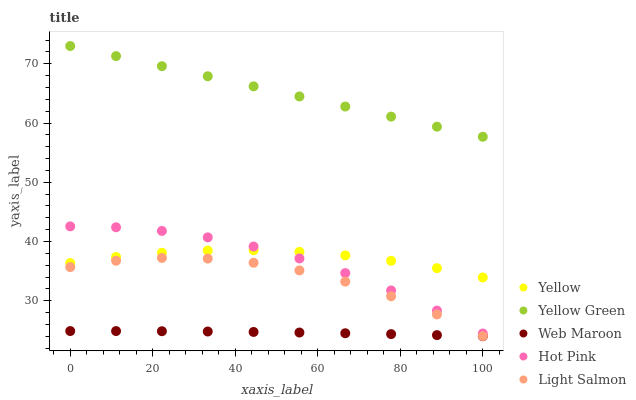Does Web Maroon have the minimum area under the curve?
Answer yes or no. Yes. Does Yellow Green have the maximum area under the curve?
Answer yes or no. Yes. Does Hot Pink have the minimum area under the curve?
Answer yes or no. No. Does Hot Pink have the maximum area under the curve?
Answer yes or no. No. Is Yellow Green the smoothest?
Answer yes or no. Yes. Is Light Salmon the roughest?
Answer yes or no. Yes. Is Hot Pink the smoothest?
Answer yes or no. No. Is Hot Pink the roughest?
Answer yes or no. No. Does Web Maroon have the lowest value?
Answer yes or no. Yes. Does Hot Pink have the lowest value?
Answer yes or no. No. Does Yellow Green have the highest value?
Answer yes or no. Yes. Does Hot Pink have the highest value?
Answer yes or no. No. Is Web Maroon less than Yellow Green?
Answer yes or no. Yes. Is Yellow greater than Web Maroon?
Answer yes or no. Yes. Does Yellow intersect Hot Pink?
Answer yes or no. Yes. Is Yellow less than Hot Pink?
Answer yes or no. No. Is Yellow greater than Hot Pink?
Answer yes or no. No. Does Web Maroon intersect Yellow Green?
Answer yes or no. No. 